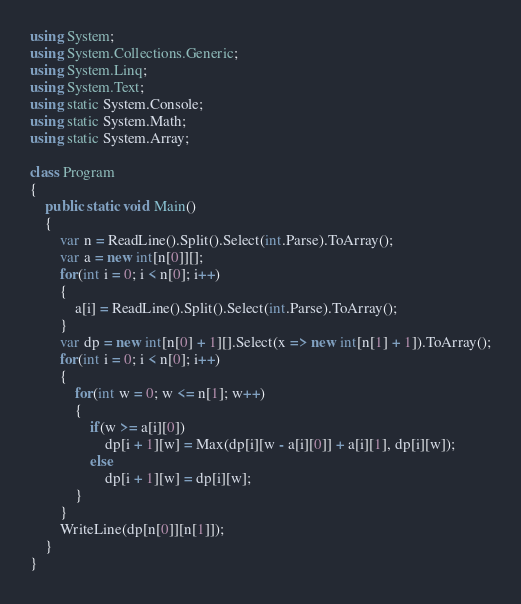<code> <loc_0><loc_0><loc_500><loc_500><_C#_>using System;
using System.Collections.Generic;
using System.Linq;
using System.Text;
using static System.Console;
using static System.Math;
using static System.Array;

class Program
{
    public static void Main()
    {
        var n = ReadLine().Split().Select(int.Parse).ToArray();
        var a = new int[n[0]][];
        for(int i = 0; i < n[0]; i++)
        {
            a[i] = ReadLine().Split().Select(int.Parse).ToArray();
        }
        var dp = new int[n[0] + 1][].Select(x => new int[n[1] + 1]).ToArray();
        for(int i = 0; i < n[0]; i++)
        {
            for(int w = 0; w <= n[1]; w++)
            {
                if(w >= a[i][0])
                    dp[i + 1][w] = Max(dp[i][w - a[i][0]] + a[i][1], dp[i][w]);
                else
                    dp[i + 1][w] = dp[i][w];
            }
        }
        WriteLine(dp[n[0]][n[1]]);
    }
}
</code> 